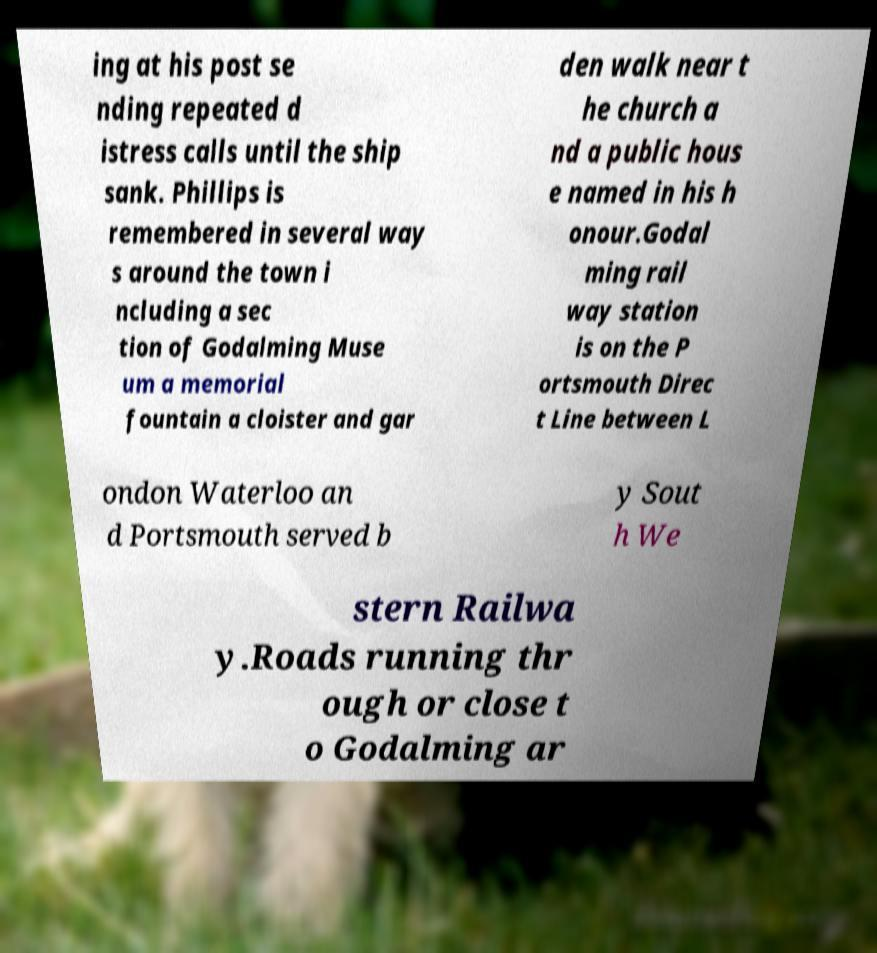For documentation purposes, I need the text within this image transcribed. Could you provide that? ing at his post se nding repeated d istress calls until the ship sank. Phillips is remembered in several way s around the town i ncluding a sec tion of Godalming Muse um a memorial fountain a cloister and gar den walk near t he church a nd a public hous e named in his h onour.Godal ming rail way station is on the P ortsmouth Direc t Line between L ondon Waterloo an d Portsmouth served b y Sout h We stern Railwa y.Roads running thr ough or close t o Godalming ar 